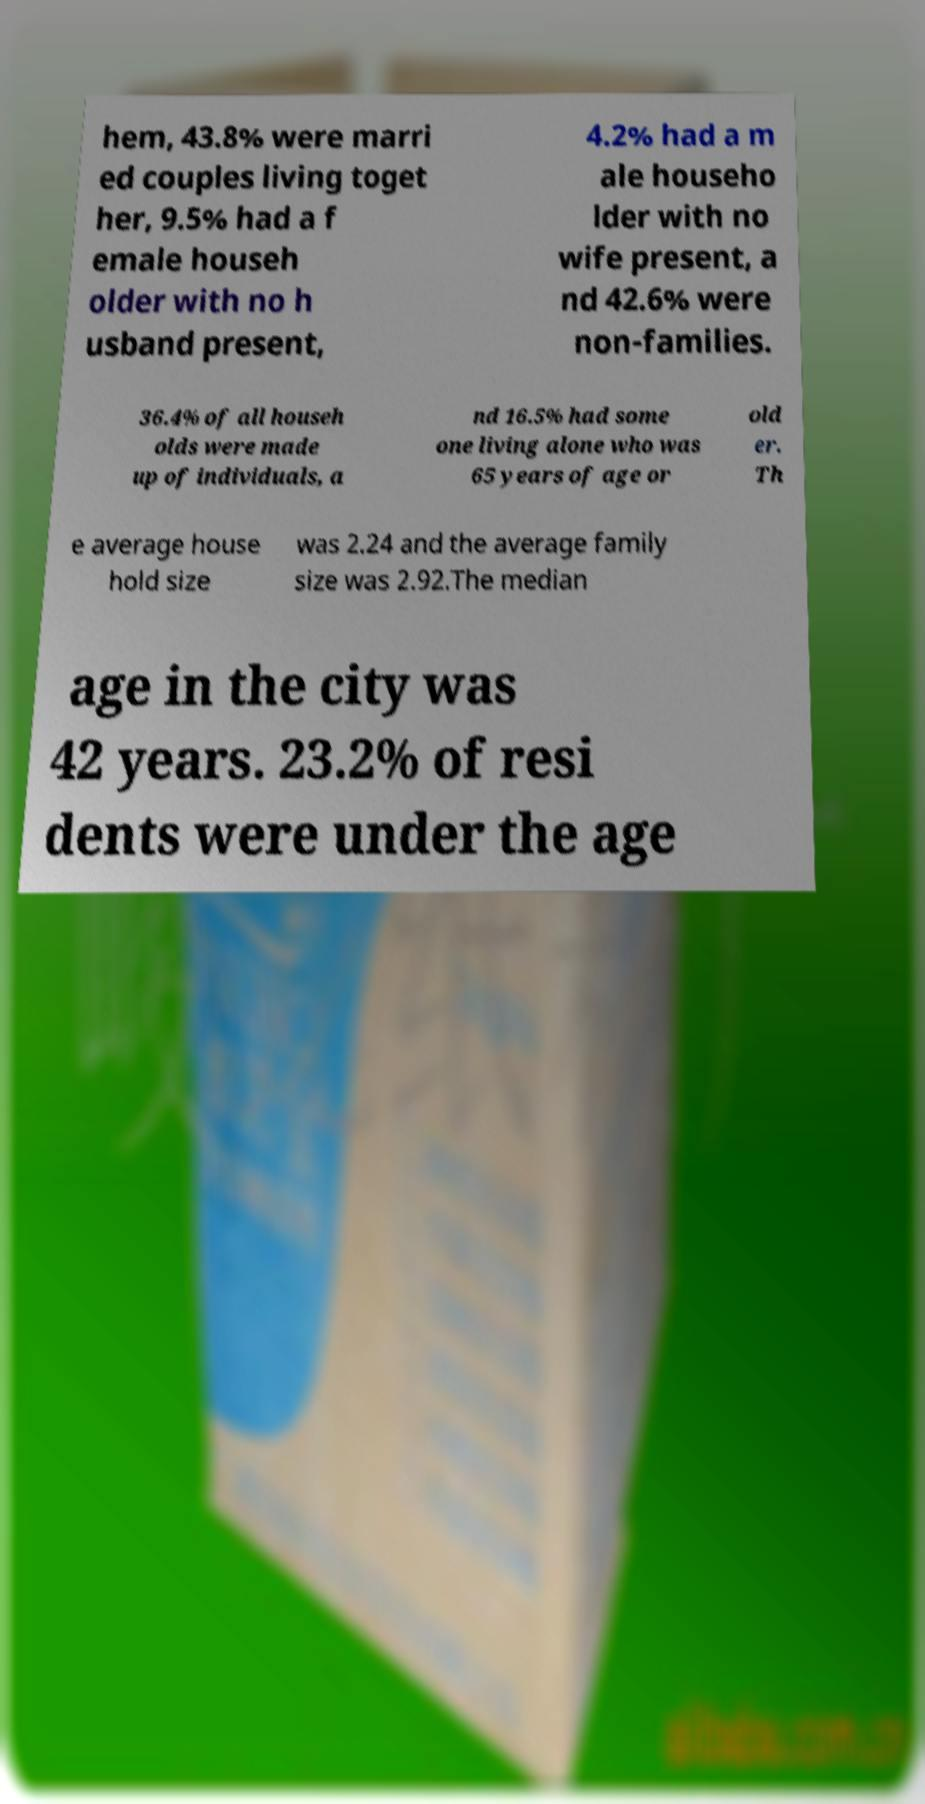What messages or text are displayed in this image? I need them in a readable, typed format. hem, 43.8% were marri ed couples living toget her, 9.5% had a f emale househ older with no h usband present, 4.2% had a m ale househo lder with no wife present, a nd 42.6% were non-families. 36.4% of all househ olds were made up of individuals, a nd 16.5% had some one living alone who was 65 years of age or old er. Th e average house hold size was 2.24 and the average family size was 2.92.The median age in the city was 42 years. 23.2% of resi dents were under the age 